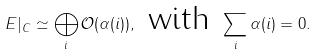Convert formula to latex. <formula><loc_0><loc_0><loc_500><loc_500>E | _ { C } \simeq \bigoplus _ { i } \mathcal { O } ( \alpha ( i ) ) , \text { with } \sum _ { i } \alpha ( i ) = 0 .</formula> 